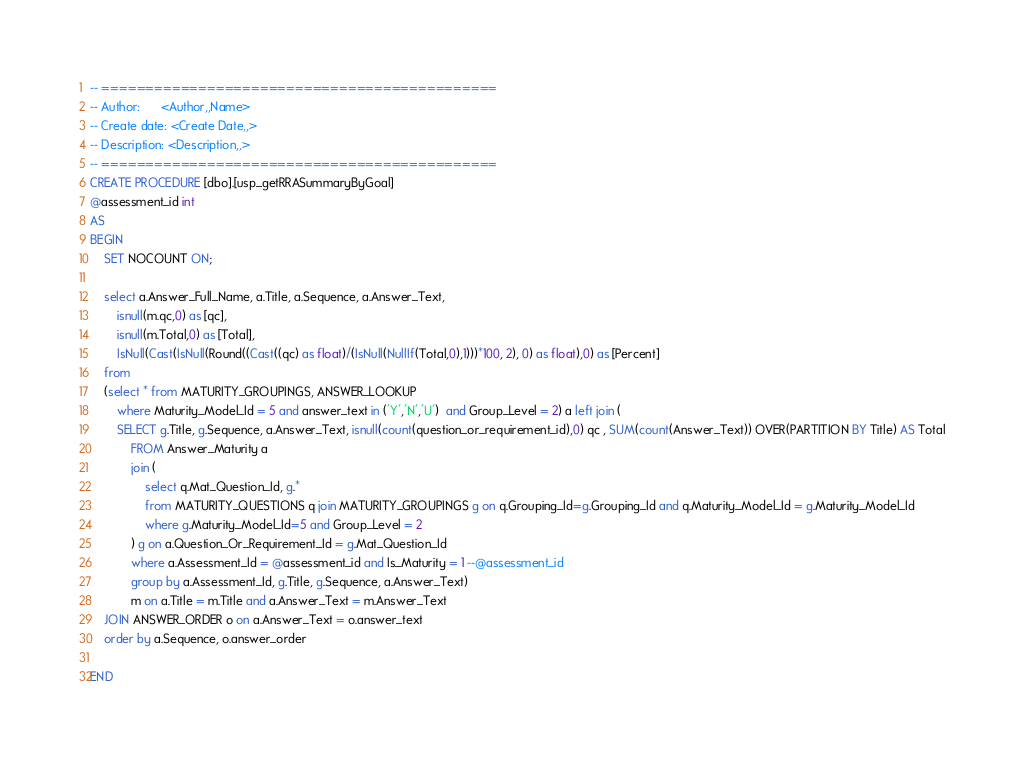Convert code to text. <code><loc_0><loc_0><loc_500><loc_500><_SQL_>-- =============================================
-- Author:		<Author,,Name>
-- Create date: <Create Date,,>
-- Description:	<Description,,>
-- =============================================
CREATE PROCEDURE [dbo].[usp_getRRASummaryByGoal]
@assessment_id int
AS
BEGIN
	SET NOCOUNT ON;

	select a.Answer_Full_Name, a.Title, a.Sequence, a.Answer_Text, 
		isnull(m.qc,0) as [qc],
		isnull(m.Total,0) as [Total], 
		IsNull(Cast(IsNull(Round((Cast((qc) as float)/(IsNull(NullIf(Total,0),1)))*100, 2), 0) as float),0) as [Percent] 
	from 	
	(select * from MATURITY_GROUPINGS, ANSWER_LOOKUP 
		where Maturity_Model_Id = 5 and answer_text in ('Y','N','U')  and Group_Level = 2) a left join (
		SELECT g.Title, g.Sequence, a.Answer_Text, isnull(count(question_or_requirement_id),0) qc , SUM(count(Answer_Text)) OVER(PARTITION BY Title) AS Total
			FROM Answer_Maturity a 
			join (
				select q.Mat_Question_Id, g.* 
				from MATURITY_QUESTIONS q join MATURITY_GROUPINGS g on q.Grouping_Id=g.Grouping_Id and q.Maturity_Model_Id = g.Maturity_Model_Id
				where g.Maturity_Model_Id=5 and Group_Level = 2
			) g on a.Question_Or_Requirement_Id = g.Mat_Question_Id
			where a.Assessment_Id = @assessment_id and Is_Maturity = 1 --@assessment_id 			
			group by a.Assessment_Id, g.Title, g.Sequence, a.Answer_Text)
			m on a.Title = m.Title and a.Answer_Text = m.Answer_Text
	JOIN ANSWER_ORDER o on a.Answer_Text = o.answer_text
	order by a.Sequence, o.answer_order

END

</code> 